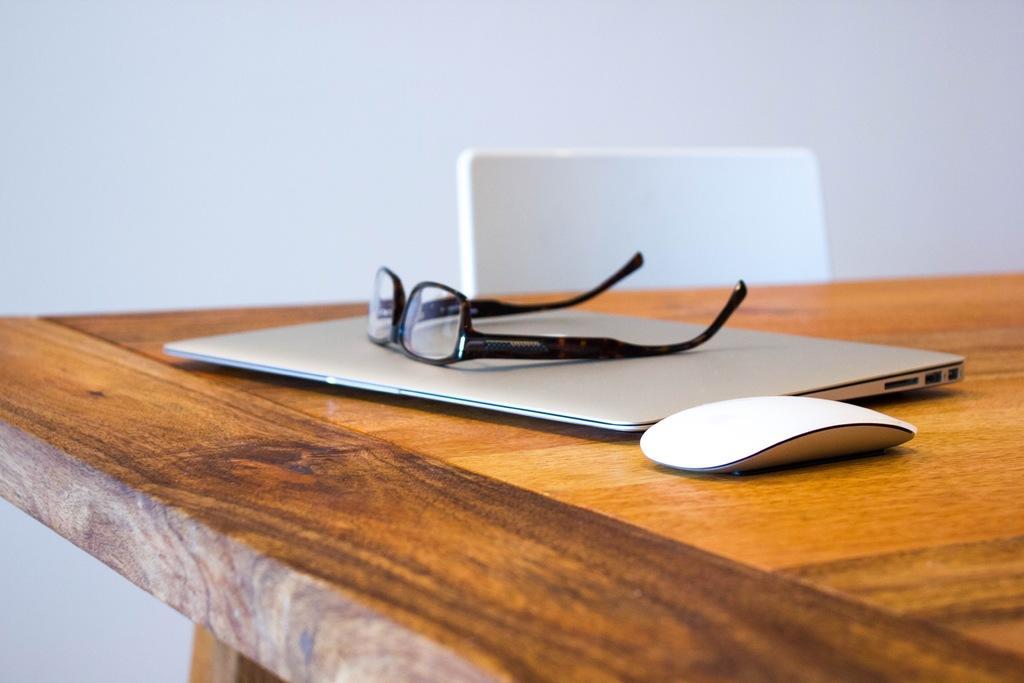Describe this image in one or two sentences. In this image there is one table and on that table there is one laptop mouse spectacles are there beside the table there is one chair on the top there is wall. 